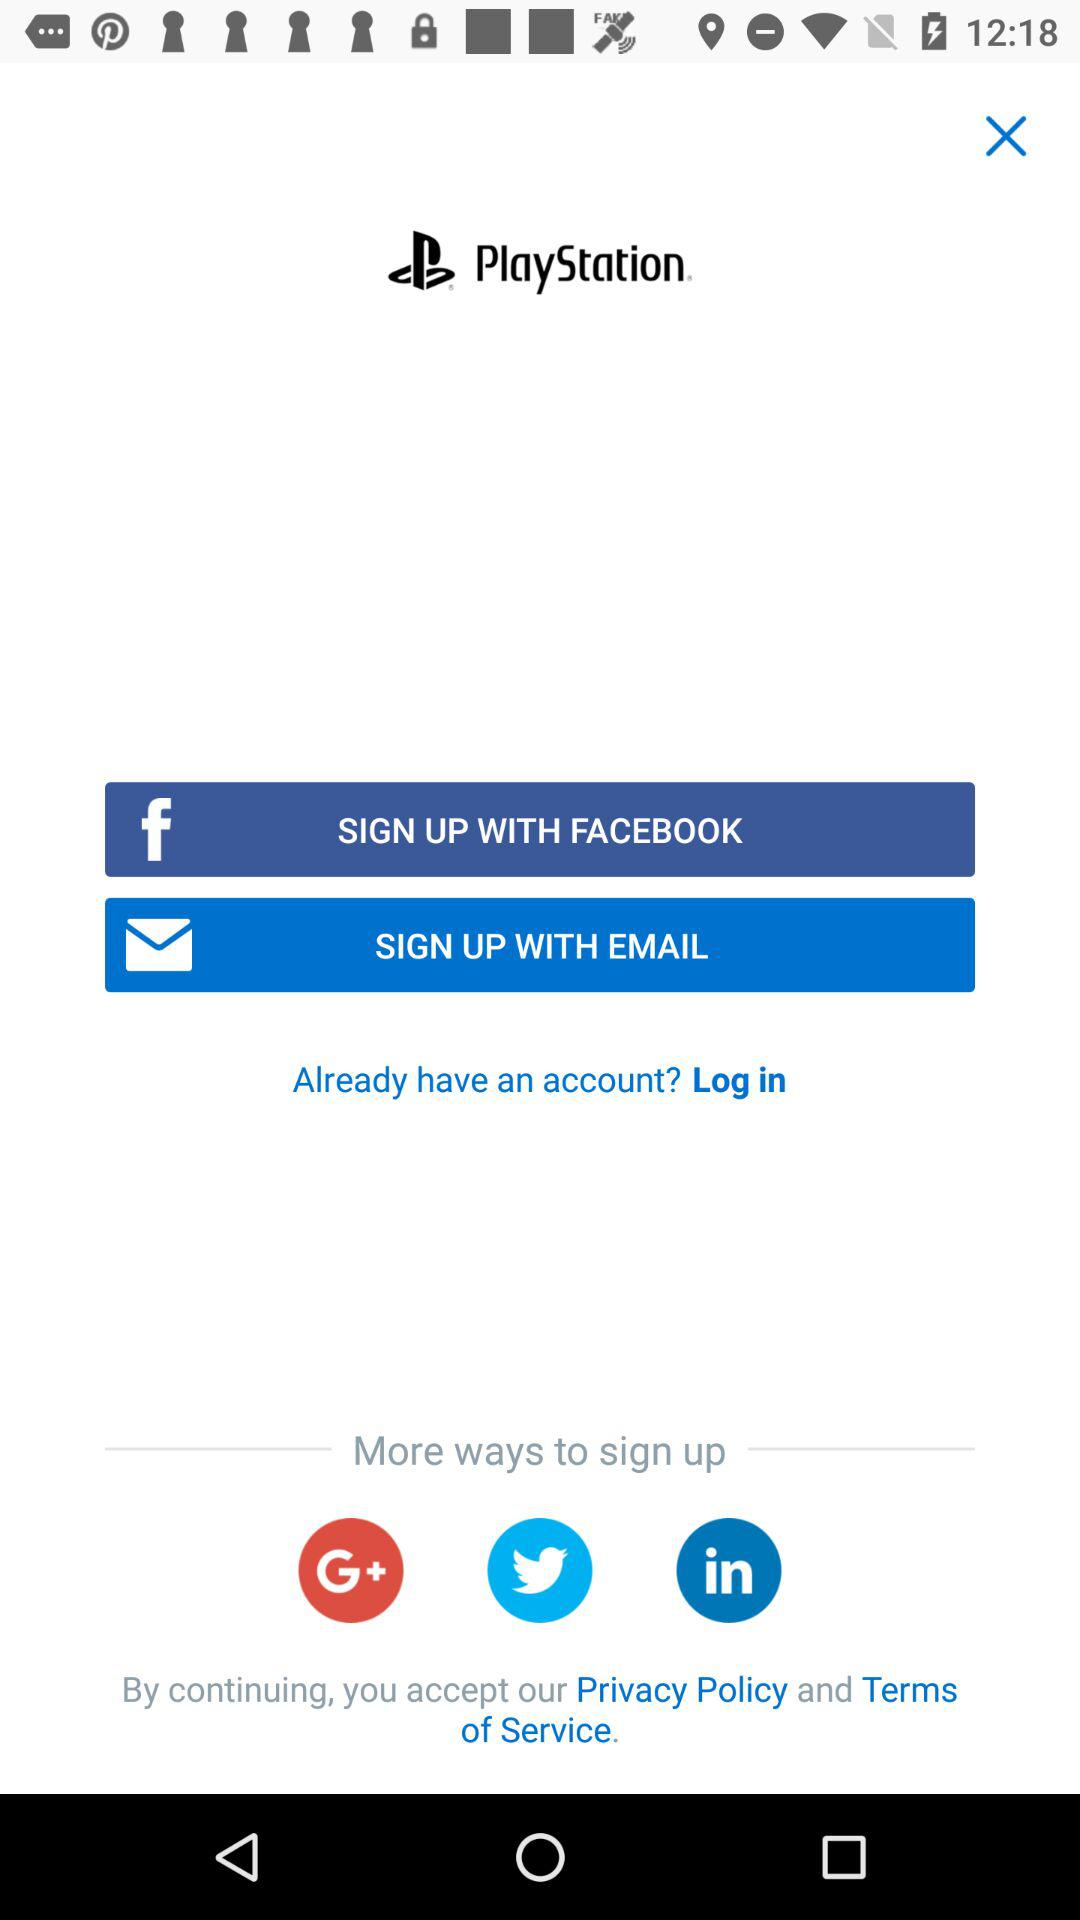What are the other ways given to sign up? The other ways given to sign up are "Google+", "Twitter" and "LinkedIn". 